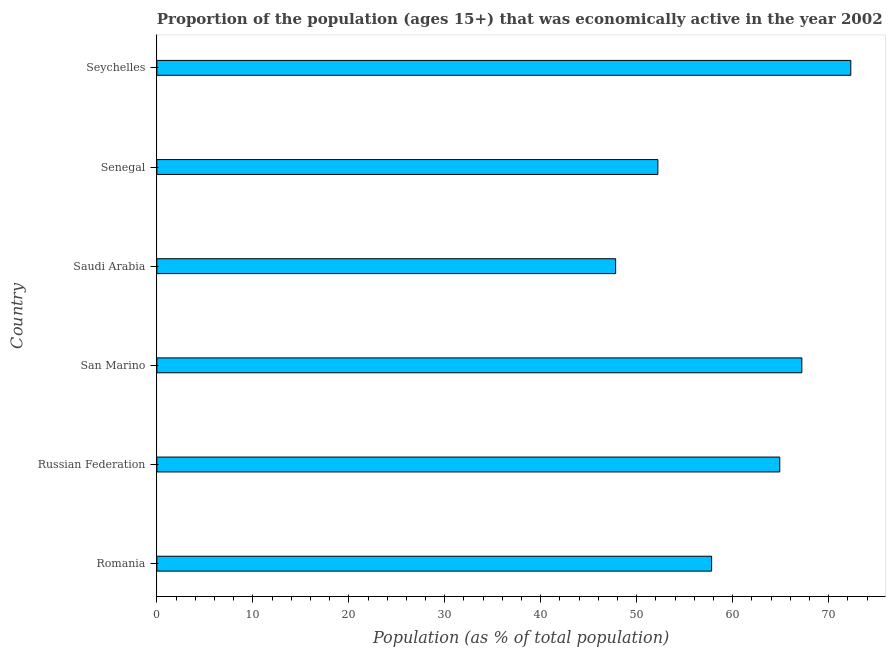What is the title of the graph?
Make the answer very short. Proportion of the population (ages 15+) that was economically active in the year 2002. What is the label or title of the X-axis?
Your response must be concise. Population (as % of total population). What is the percentage of economically active population in Russian Federation?
Offer a terse response. 64.9. Across all countries, what is the maximum percentage of economically active population?
Your response must be concise. 72.3. Across all countries, what is the minimum percentage of economically active population?
Ensure brevity in your answer.  47.8. In which country was the percentage of economically active population maximum?
Your answer should be very brief. Seychelles. In which country was the percentage of economically active population minimum?
Your answer should be very brief. Saudi Arabia. What is the sum of the percentage of economically active population?
Offer a very short reply. 362.2. What is the difference between the percentage of economically active population in Saudi Arabia and Seychelles?
Your response must be concise. -24.5. What is the average percentage of economically active population per country?
Provide a succinct answer. 60.37. What is the median percentage of economically active population?
Keep it short and to the point. 61.35. In how many countries, is the percentage of economically active population greater than 52 %?
Your response must be concise. 5. What is the ratio of the percentage of economically active population in Romania to that in Seychelles?
Your response must be concise. 0.8. Is the percentage of economically active population in Russian Federation less than that in Senegal?
Offer a terse response. No. Is the difference between the percentage of economically active population in San Marino and Senegal greater than the difference between any two countries?
Give a very brief answer. No. Is the sum of the percentage of economically active population in Saudi Arabia and Senegal greater than the maximum percentage of economically active population across all countries?
Your answer should be very brief. Yes. In how many countries, is the percentage of economically active population greater than the average percentage of economically active population taken over all countries?
Offer a terse response. 3. How many bars are there?
Offer a very short reply. 6. What is the difference between two consecutive major ticks on the X-axis?
Ensure brevity in your answer.  10. What is the Population (as % of total population) of Romania?
Your answer should be very brief. 57.8. What is the Population (as % of total population) of Russian Federation?
Provide a succinct answer. 64.9. What is the Population (as % of total population) of San Marino?
Make the answer very short. 67.2. What is the Population (as % of total population) of Saudi Arabia?
Offer a terse response. 47.8. What is the Population (as % of total population) in Senegal?
Your answer should be very brief. 52.2. What is the Population (as % of total population) of Seychelles?
Your response must be concise. 72.3. What is the difference between the Population (as % of total population) in Romania and San Marino?
Offer a terse response. -9.4. What is the difference between the Population (as % of total population) in Romania and Seychelles?
Provide a short and direct response. -14.5. What is the difference between the Population (as % of total population) in Russian Federation and Seychelles?
Give a very brief answer. -7.4. What is the difference between the Population (as % of total population) in San Marino and Saudi Arabia?
Provide a succinct answer. 19.4. What is the difference between the Population (as % of total population) in San Marino and Seychelles?
Provide a short and direct response. -5.1. What is the difference between the Population (as % of total population) in Saudi Arabia and Seychelles?
Keep it short and to the point. -24.5. What is the difference between the Population (as % of total population) in Senegal and Seychelles?
Keep it short and to the point. -20.1. What is the ratio of the Population (as % of total population) in Romania to that in Russian Federation?
Ensure brevity in your answer.  0.89. What is the ratio of the Population (as % of total population) in Romania to that in San Marino?
Give a very brief answer. 0.86. What is the ratio of the Population (as % of total population) in Romania to that in Saudi Arabia?
Provide a short and direct response. 1.21. What is the ratio of the Population (as % of total population) in Romania to that in Senegal?
Give a very brief answer. 1.11. What is the ratio of the Population (as % of total population) in Romania to that in Seychelles?
Keep it short and to the point. 0.8. What is the ratio of the Population (as % of total population) in Russian Federation to that in San Marino?
Your answer should be compact. 0.97. What is the ratio of the Population (as % of total population) in Russian Federation to that in Saudi Arabia?
Offer a very short reply. 1.36. What is the ratio of the Population (as % of total population) in Russian Federation to that in Senegal?
Make the answer very short. 1.24. What is the ratio of the Population (as % of total population) in Russian Federation to that in Seychelles?
Ensure brevity in your answer.  0.9. What is the ratio of the Population (as % of total population) in San Marino to that in Saudi Arabia?
Your answer should be very brief. 1.41. What is the ratio of the Population (as % of total population) in San Marino to that in Senegal?
Ensure brevity in your answer.  1.29. What is the ratio of the Population (as % of total population) in San Marino to that in Seychelles?
Offer a terse response. 0.93. What is the ratio of the Population (as % of total population) in Saudi Arabia to that in Senegal?
Your answer should be very brief. 0.92. What is the ratio of the Population (as % of total population) in Saudi Arabia to that in Seychelles?
Provide a succinct answer. 0.66. What is the ratio of the Population (as % of total population) in Senegal to that in Seychelles?
Give a very brief answer. 0.72. 